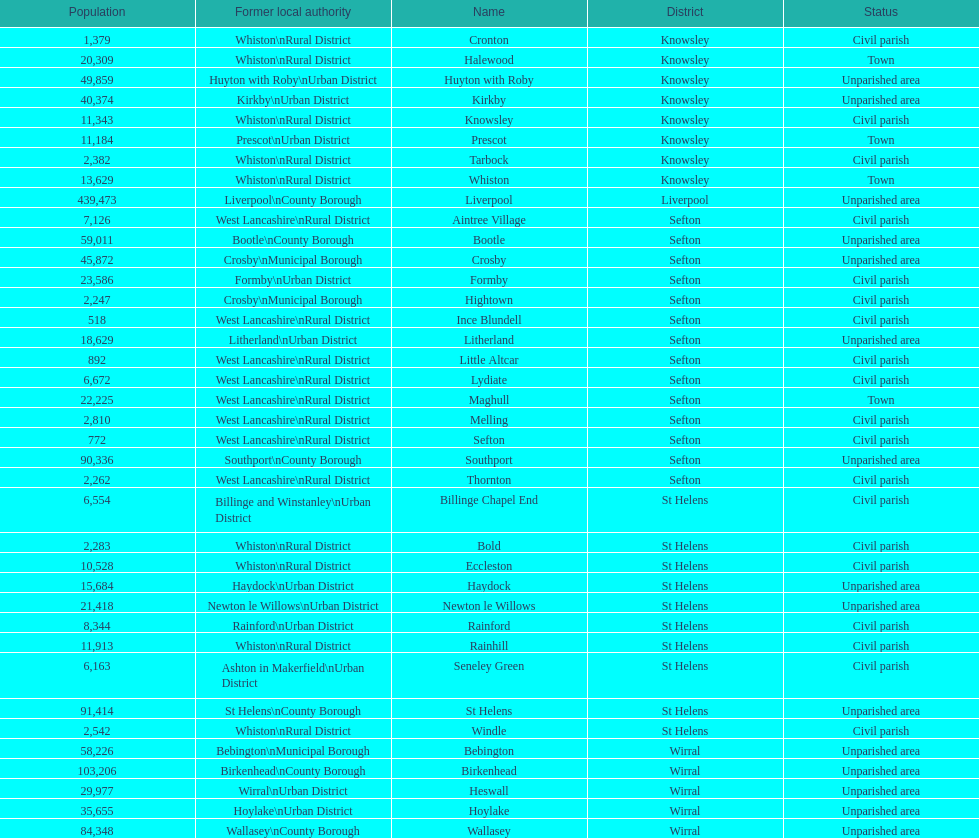Which area has the least number of residents? Ince Blundell. 